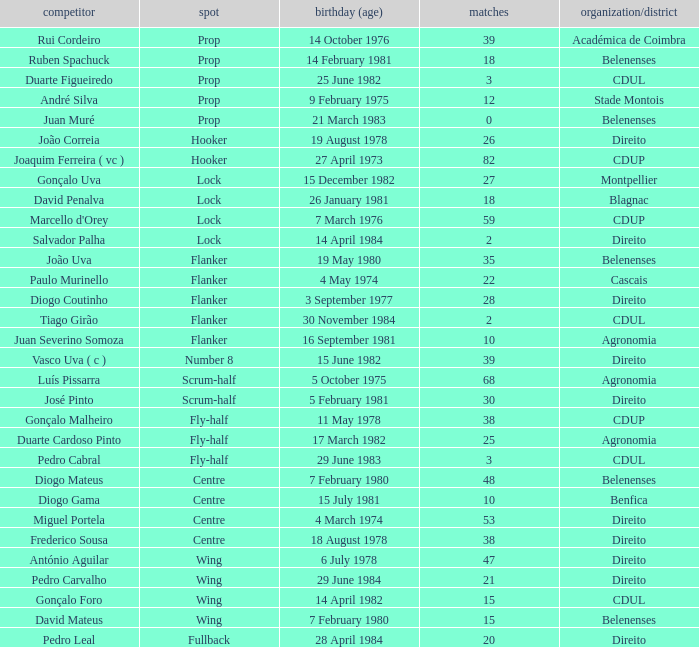How many caps have a Date of Birth (Age) of 15 july 1981? 1.0. 